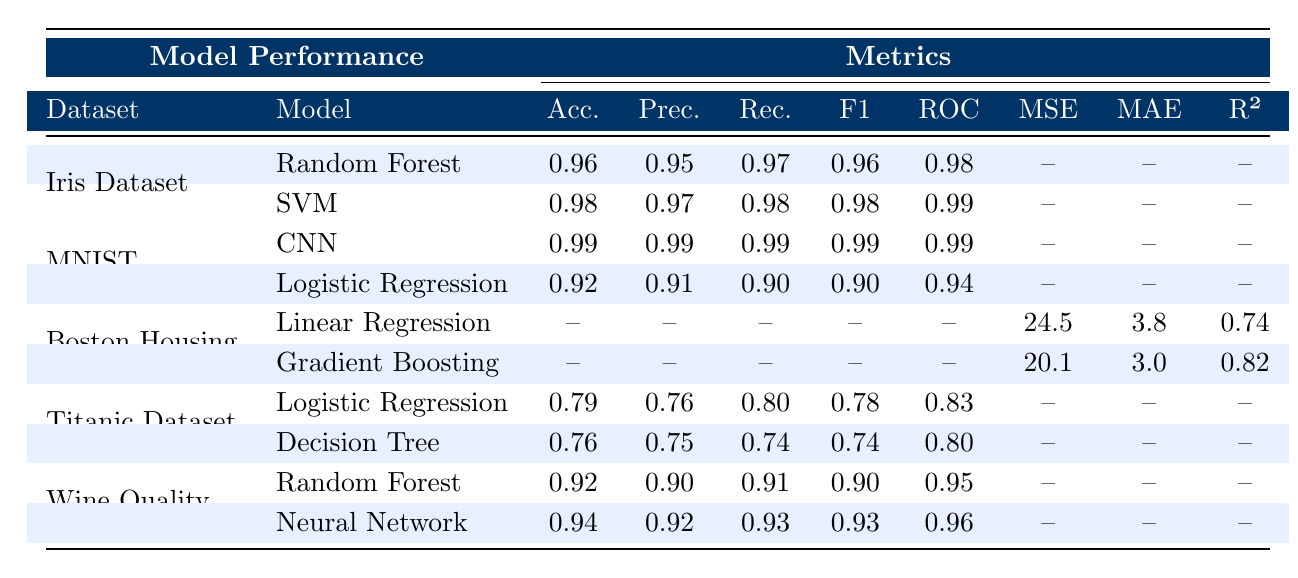What is the accuracy of the SVM model on the Iris Dataset? The table shows the accuracy for the SVM model in the row corresponding to the Iris Dataset, which is 0.98.
Answer: 0.98 Which model has the highest accuracy on the MNIST dataset? The CNN model is listed in the table as having an accuracy of 0.99, while Logistic Regression has 0.92. Therefore, the CNN model has the highest accuracy.
Answer: CNN Is the precision of the Random Forest model on the Wine Quality dataset greater than 0.90? The table indicates that the precision of the Random Forest model on the Wine Quality dataset is 0.90, which is equal to 0.90, and not greater.
Answer: No Calculate the difference in accuracy between the best performing model and the Decision Tree model on the Titanic dataset. The Decision Tree model has an accuracy of 0.76, while the best performing model on the Titanic dataset, which is Logistic Regression, has an accuracy of 0.79. The difference is 0.79 - 0.76 = 0.03.
Answer: 0.03 Which model has the highest ROC AUC score across all datasets? By comparing the ROC AUC scores listed, SVM (0.99), CNN (0.99), and Neural Network (0.96) have the highest scores, but SVM is the first occurrence with that score. Thus, SVM holds the highest ROC AUC score.
Answer: SVM What is the mean squared error (MSE) of the Gradient Boosting model on the Boston Housing dataset? The table shows that the MSE for the Gradient Boosting model on the Boston Housing dataset is 20.1.
Answer: 20.1 Does the Logistic Regression model on the Titanic dataset have a higher recall than the Decision Tree model? The recall values for the Logistic Regression model and Decision Tree model on the Titanic dataset are 0.80 and 0.74, respectively. Since 0.80 is greater than 0.74, the answer is yes.
Answer: Yes How does the R-squared value of the Gradient Boosting model compare with that of Linear Regression on the Boston Housing dataset? The R-squared value for Gradient Boosting is 0.82 and for Linear Regression, it is 0.74. Since 0.82 is greater than 0.74, Gradient Boosting has a higher R-squared value.
Answer: 0.82 is greater than 0.74 What is the average accuracy of the models on the Wine Quality dataset? The Random Forest model has an accuracy of 0.92 and the Neural Network has 0.94. The average accuracy is (0.92 + 0.94) / 2 = 0.93.
Answer: 0.93 Which model on the MNIST dataset has the lowest precision? The Logistic Regression model has a precision of 0.91, while the CNN has a precision of 0.99. Therefore, the Logistic Regression model has the lowest precision on the MNIST dataset.
Answer: Logistic Regression 